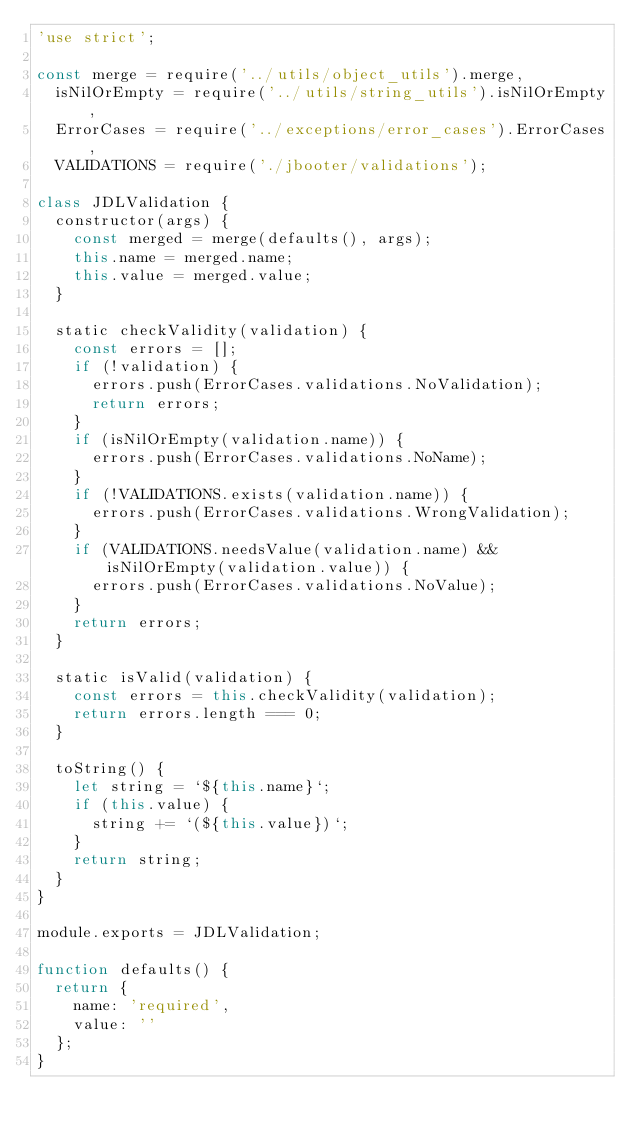Convert code to text. <code><loc_0><loc_0><loc_500><loc_500><_JavaScript_>'use strict';

const merge = require('../utils/object_utils').merge,
  isNilOrEmpty = require('../utils/string_utils').isNilOrEmpty,
  ErrorCases = require('../exceptions/error_cases').ErrorCases,
  VALIDATIONS = require('./jbooter/validations');

class JDLValidation {
  constructor(args) {
    const merged = merge(defaults(), args);
    this.name = merged.name;
    this.value = merged.value;
  }

  static checkValidity(validation) {
    const errors = [];
    if (!validation) {
      errors.push(ErrorCases.validations.NoValidation);
      return errors;
    }
    if (isNilOrEmpty(validation.name)) {
      errors.push(ErrorCases.validations.NoName);
    }
    if (!VALIDATIONS.exists(validation.name)) {
      errors.push(ErrorCases.validations.WrongValidation);
    }
    if (VALIDATIONS.needsValue(validation.name) && isNilOrEmpty(validation.value)) {
      errors.push(ErrorCases.validations.NoValue);
    }
    return errors;
  }

  static isValid(validation) {
    const errors = this.checkValidity(validation);
    return errors.length === 0;
  }

  toString() {
    let string = `${this.name}`;
    if (this.value) {
      string += `(${this.value})`;
    }
    return string;
  }
}

module.exports = JDLValidation;

function defaults() {
  return {
    name: 'required',
    value: ''
  };
}
</code> 